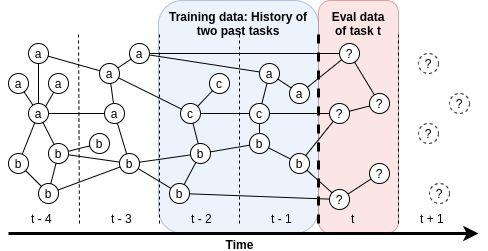Please explain how the introduction of component 'c' at time t-2 affects the evaluation methodology for tasks. The introduction of component 'c' at time t-2 suggests a pivotal shift in the evaluation methodology. By incorporating 'c', the framework adapts to possibly include new metrics or perspectives that are critical from t-2 onward. This inclusion could represent an enhancement in assessing certain qualities or performances of tasks that were not previously measured, leading to potentially more comprehensive and robust evaluations. 